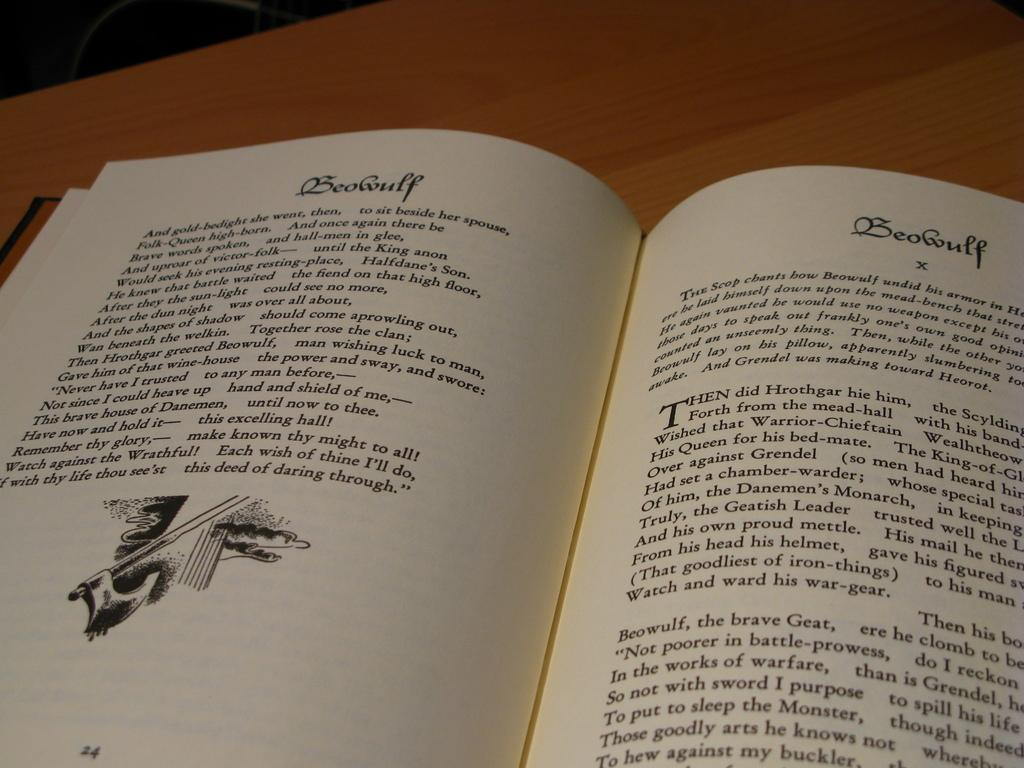<image>
Render a clear and concise summary of the photo. A book is open on a table displaying the story of Beowulf. 